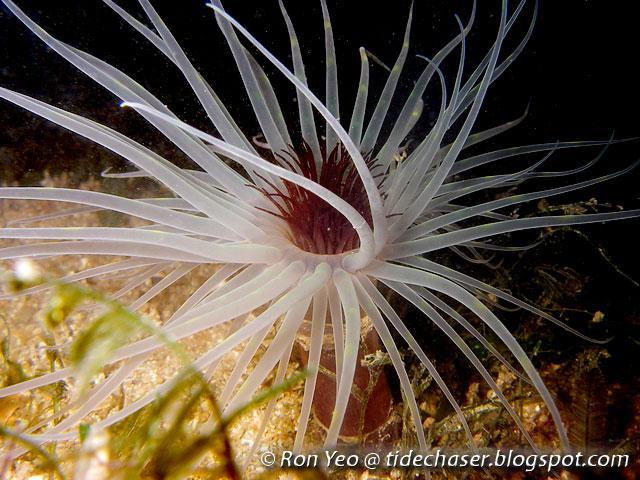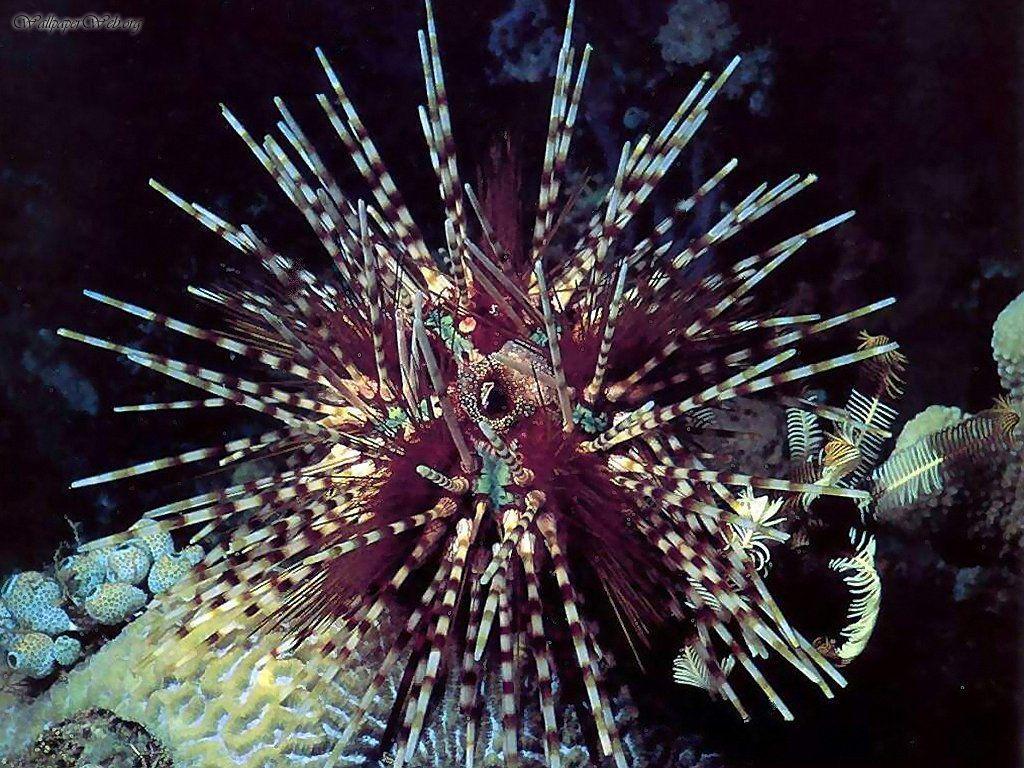The first image is the image on the left, the second image is the image on the right. Examine the images to the left and right. Is the description "One image features a single jellyfish with spiky, non-rounded tendrils that are two-toned in white and another color." accurate? Answer yes or no. Yes. 